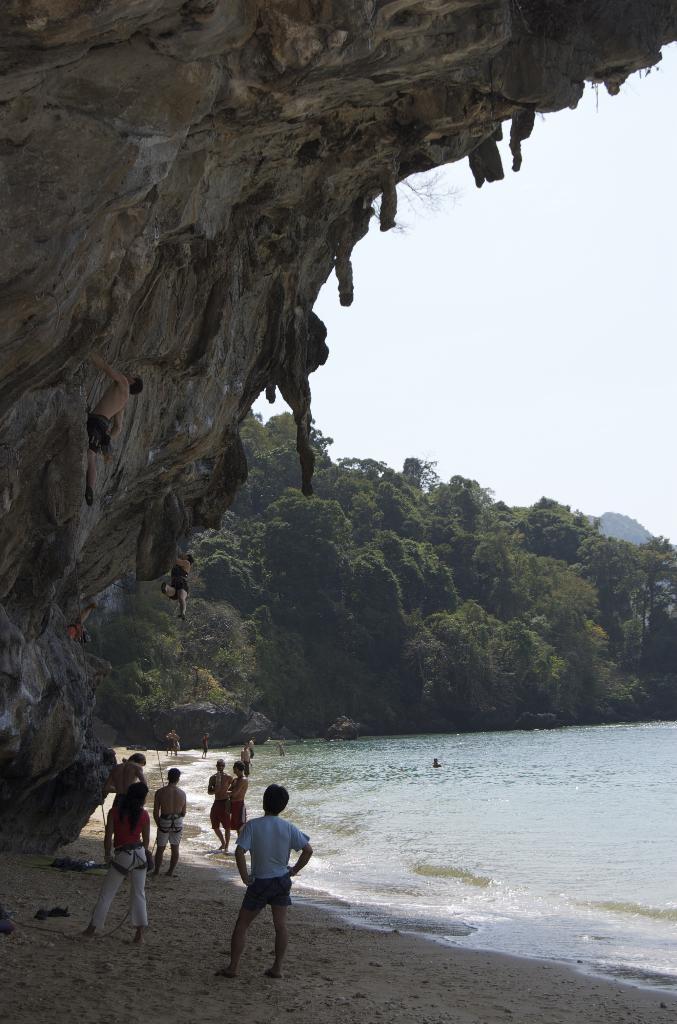Describe this image in one or two sentences. At the bottom of the image there is a sea shore with few people are standing. At the left corner there is a hill and few people are climbing on it. And at the right side of the image there is water. In the background there are trees and also there is a sky. 